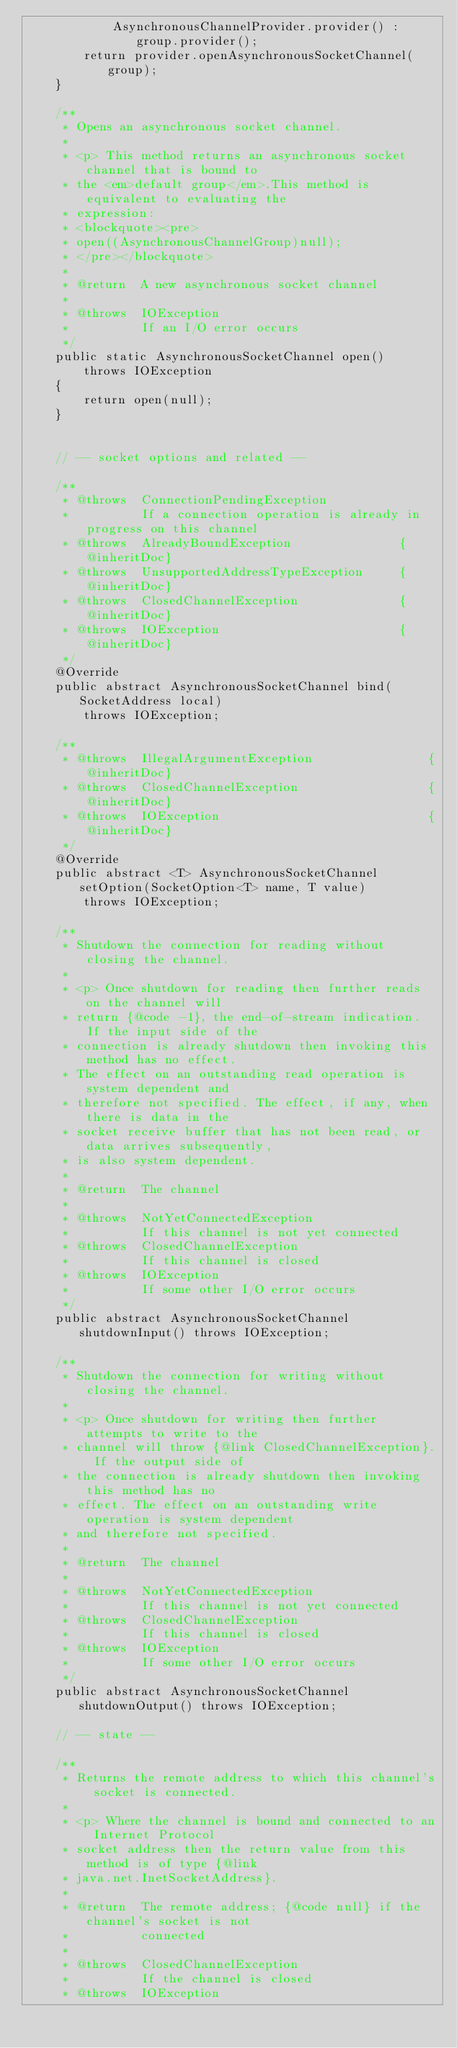Convert code to text. <code><loc_0><loc_0><loc_500><loc_500><_Java_>            AsynchronousChannelProvider.provider() : group.provider();
        return provider.openAsynchronousSocketChannel(group);
    }

    /**
     * Opens an asynchronous socket channel.
     *
     * <p> This method returns an asynchronous socket channel that is bound to
     * the <em>default group</em>.This method is equivalent to evaluating the
     * expression:
     * <blockquote><pre>
     * open((AsynchronousChannelGroup)null);
     * </pre></blockquote>
     *
     * @return  A new asynchronous socket channel
     *
     * @throws  IOException
     *          If an I/O error occurs
     */
    public static AsynchronousSocketChannel open()
        throws IOException
    {
        return open(null);
    }


    // -- socket options and related --

    /**
     * @throws  ConnectionPendingException
     *          If a connection operation is already in progress on this channel
     * @throws  AlreadyBoundException               {@inheritDoc}
     * @throws  UnsupportedAddressTypeException     {@inheritDoc}
     * @throws  ClosedChannelException              {@inheritDoc}
     * @throws  IOException                         {@inheritDoc}
     */
    @Override
    public abstract AsynchronousSocketChannel bind(SocketAddress local)
        throws IOException;

    /**
     * @throws  IllegalArgumentException                {@inheritDoc}
     * @throws  ClosedChannelException                  {@inheritDoc}
     * @throws  IOException                             {@inheritDoc}
     */
    @Override
    public abstract <T> AsynchronousSocketChannel setOption(SocketOption<T> name, T value)
        throws IOException;

    /**
     * Shutdown the connection for reading without closing the channel.
     *
     * <p> Once shutdown for reading then further reads on the channel will
     * return {@code -1}, the end-of-stream indication. If the input side of the
     * connection is already shutdown then invoking this method has no effect.
     * The effect on an outstanding read operation is system dependent and
     * therefore not specified. The effect, if any, when there is data in the
     * socket receive buffer that has not been read, or data arrives subsequently,
     * is also system dependent.
     *
     * @return  The channel
     *
     * @throws  NotYetConnectedException
     *          If this channel is not yet connected
     * @throws  ClosedChannelException
     *          If this channel is closed
     * @throws  IOException
     *          If some other I/O error occurs
     */
    public abstract AsynchronousSocketChannel shutdownInput() throws IOException;

    /**
     * Shutdown the connection for writing without closing the channel.
     *
     * <p> Once shutdown for writing then further attempts to write to the
     * channel will throw {@link ClosedChannelException}. If the output side of
     * the connection is already shutdown then invoking this method has no
     * effect. The effect on an outstanding write operation is system dependent
     * and therefore not specified.
     *
     * @return  The channel
     *
     * @throws  NotYetConnectedException
     *          If this channel is not yet connected
     * @throws  ClosedChannelException
     *          If this channel is closed
     * @throws  IOException
     *          If some other I/O error occurs
     */
    public abstract AsynchronousSocketChannel shutdownOutput() throws IOException;

    // -- state --

    /**
     * Returns the remote address to which this channel's socket is connected.
     *
     * <p> Where the channel is bound and connected to an Internet Protocol
     * socket address then the return value from this method is of type {@link
     * java.net.InetSocketAddress}.
     *
     * @return  The remote address; {@code null} if the channel's socket is not
     *          connected
     *
     * @throws  ClosedChannelException
     *          If the channel is closed
     * @throws  IOException</code> 